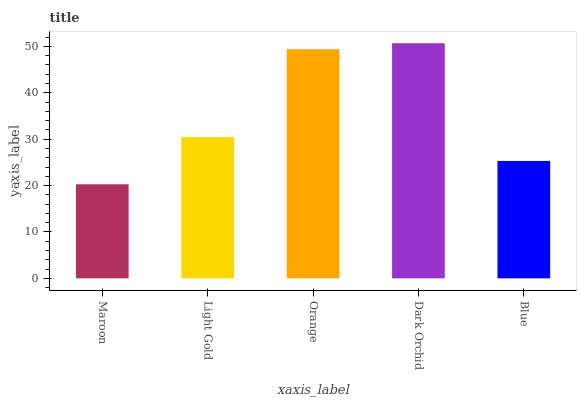Is Light Gold the minimum?
Answer yes or no. No. Is Light Gold the maximum?
Answer yes or no. No. Is Light Gold greater than Maroon?
Answer yes or no. Yes. Is Maroon less than Light Gold?
Answer yes or no. Yes. Is Maroon greater than Light Gold?
Answer yes or no. No. Is Light Gold less than Maroon?
Answer yes or no. No. Is Light Gold the high median?
Answer yes or no. Yes. Is Light Gold the low median?
Answer yes or no. Yes. Is Orange the high median?
Answer yes or no. No. Is Maroon the low median?
Answer yes or no. No. 